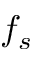Convert formula to latex. <formula><loc_0><loc_0><loc_500><loc_500>f _ { s }</formula> 